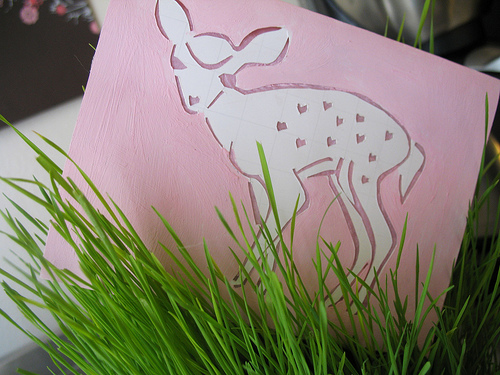<image>
Is there a paper in the grass? Yes. The paper is contained within or inside the grass, showing a containment relationship. 